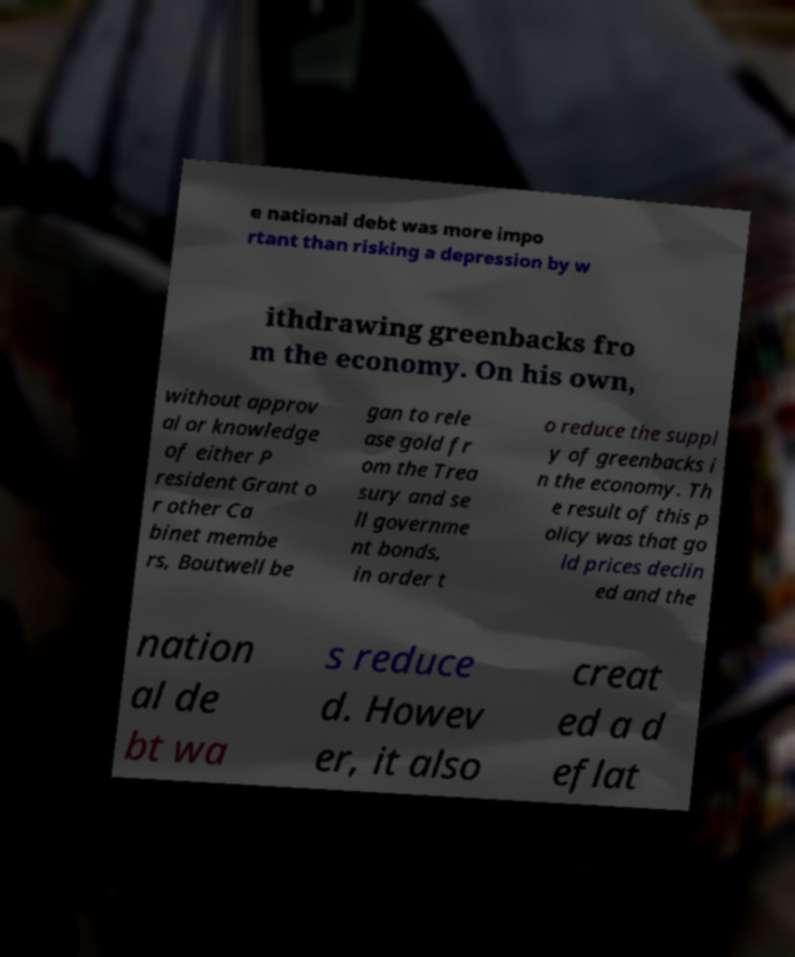What messages or text are displayed in this image? I need them in a readable, typed format. e national debt was more impo rtant than risking a depression by w ithdrawing greenbacks fro m the economy. On his own, without approv al or knowledge of either P resident Grant o r other Ca binet membe rs, Boutwell be gan to rele ase gold fr om the Trea sury and se ll governme nt bonds, in order t o reduce the suppl y of greenbacks i n the economy. Th e result of this p olicy was that go ld prices declin ed and the nation al de bt wa s reduce d. Howev er, it also creat ed a d eflat 